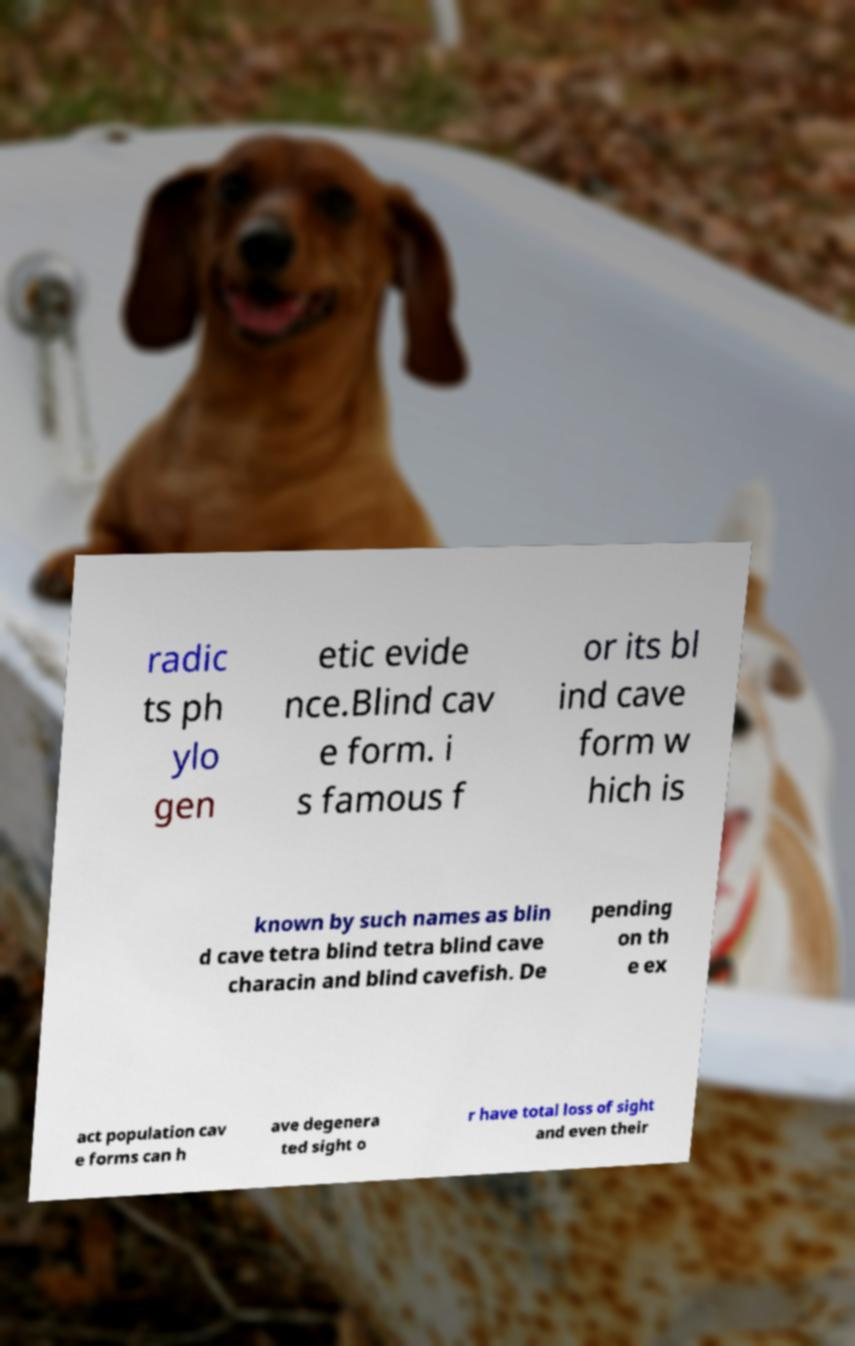For documentation purposes, I need the text within this image transcribed. Could you provide that? radic ts ph ylo gen etic evide nce.Blind cav e form. i s famous f or its bl ind cave form w hich is known by such names as blin d cave tetra blind tetra blind cave characin and blind cavefish. De pending on th e ex act population cav e forms can h ave degenera ted sight o r have total loss of sight and even their 